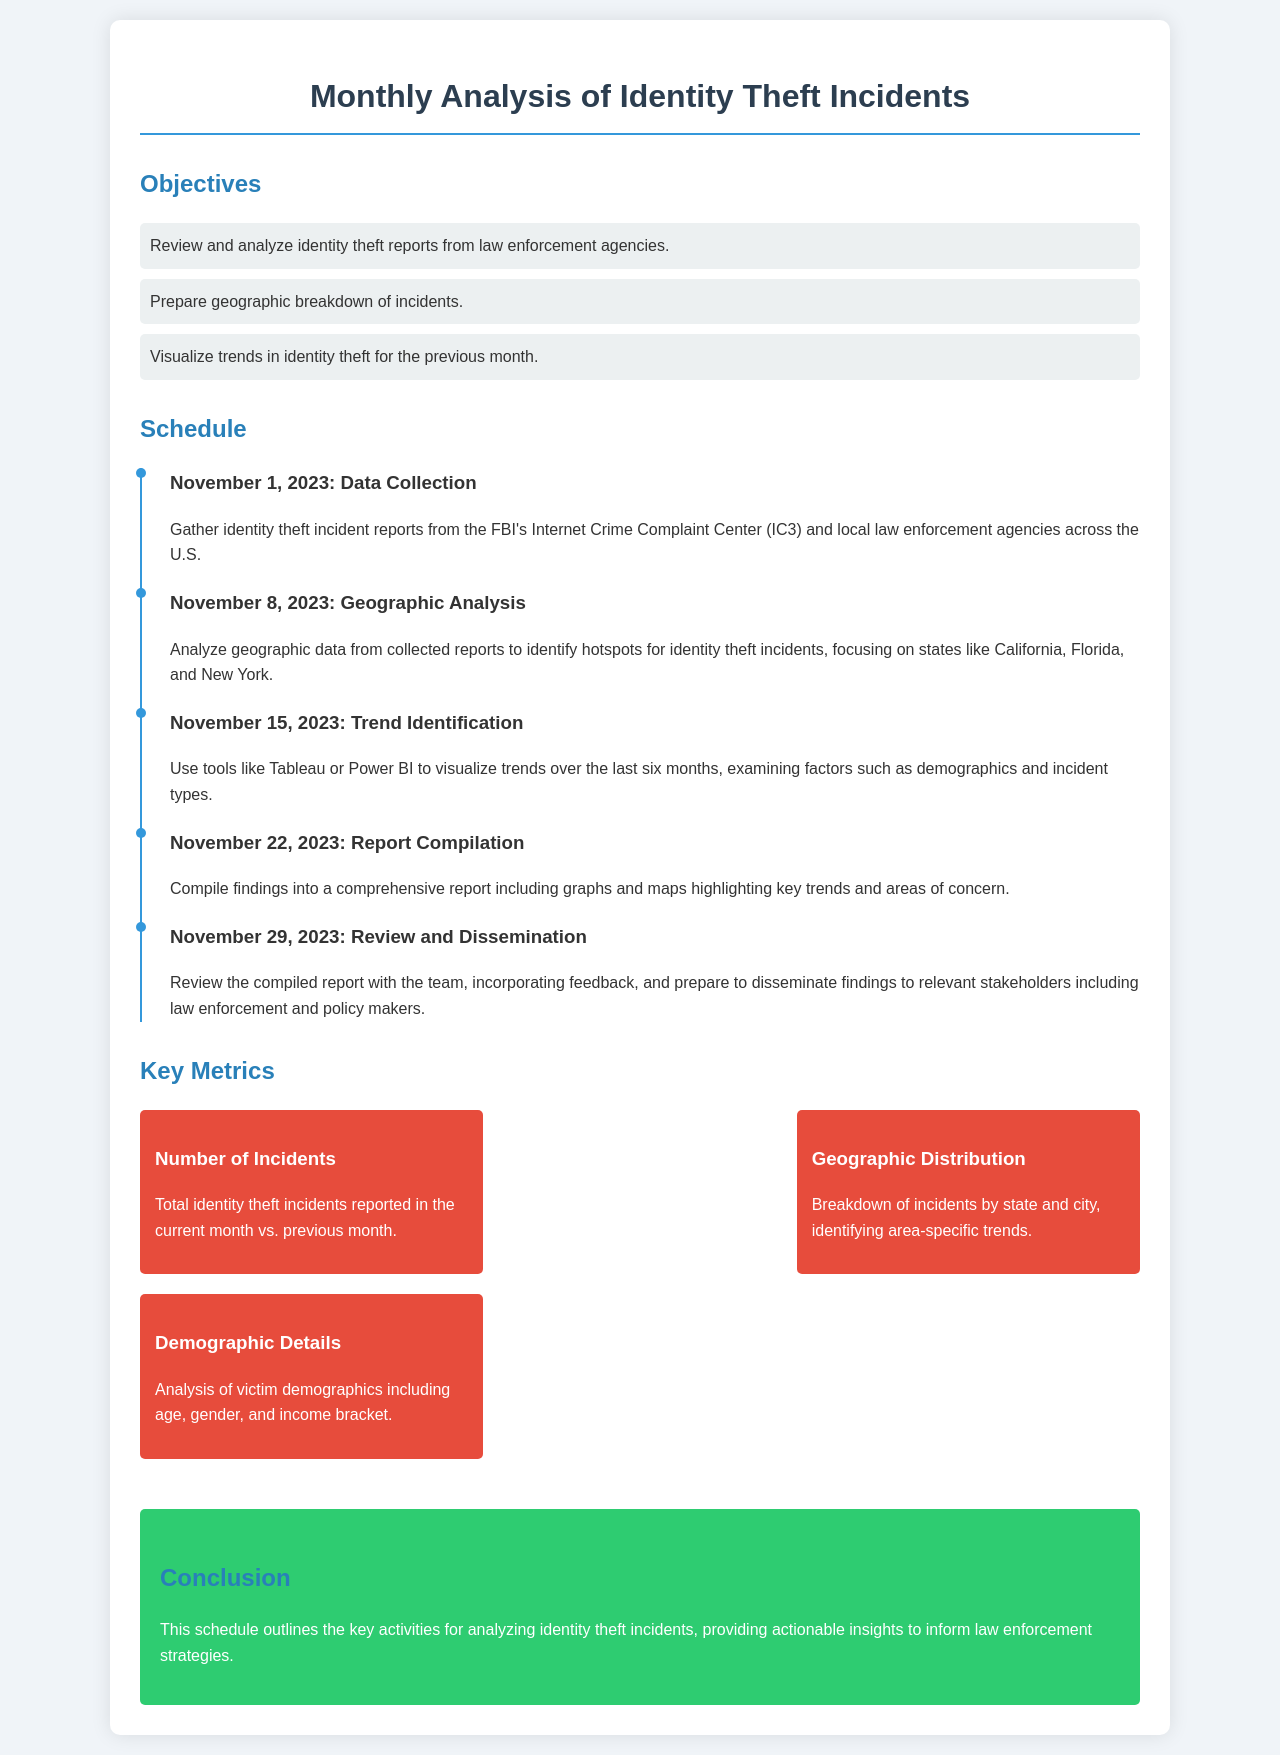what is the title of the document? The title of the document is presented prominently at the top of the rendered page.
Answer: Monthly Analysis of Identity Theft Incidents what is the first activity scheduled for November 2023? The first activity scheduled is detailed under the timeline section, which outlines the specific dates and tasks.
Answer: Data Collection how many key metrics are listed in the document? The number of metrics listed can be found under the "Key Metrics" section of the document.
Answer: Three which states are specifically mentioned for geographic analysis? The states mentioned are included in the description of the geographic analysis activity.
Answer: California, Florida, New York when is the report compilation scheduled? The date for report compilation is specified in the timeline section of the document.
Answer: November 22, 2023 what is the purpose of the conclusion section? The conclusion summarizes the overall purpose of the schedule based on information in the document.
Answer: Provide actionable insights what type of visualization tools will be used for trend identification? The tools mentioned in the document provide clarity on which applications will be utilized for visualization.
Answer: Tableau, Power BI what color is used for the background of the document body? The background color of the document is described in the style section for the body.
Answer: #f0f4f8 